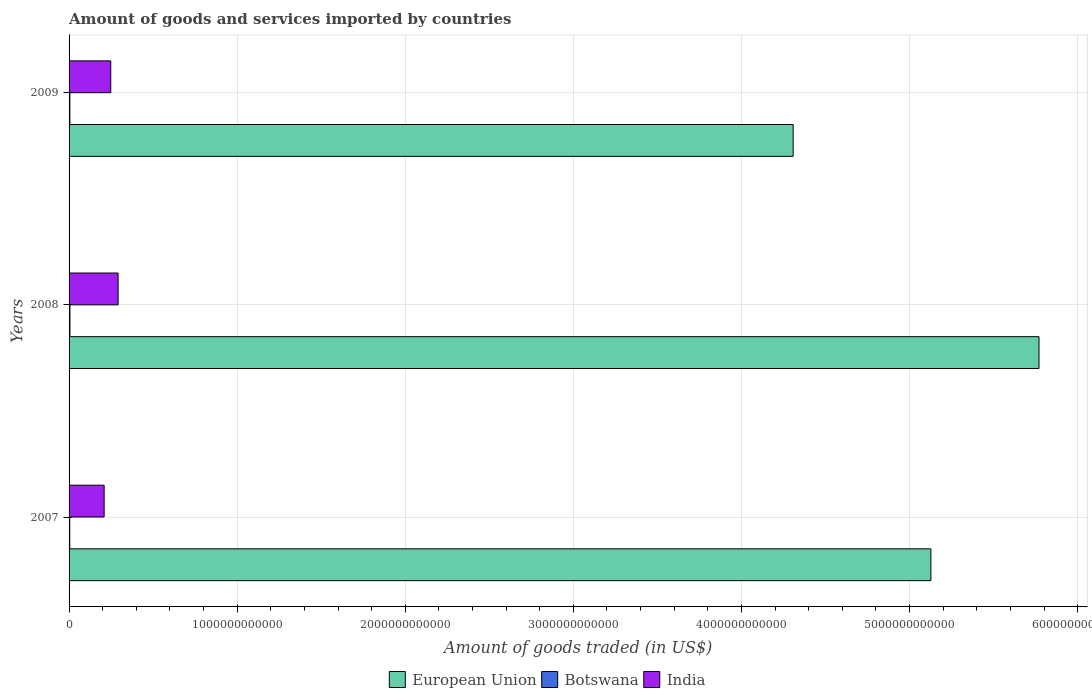How many different coloured bars are there?
Your response must be concise. 3. In how many cases, is the number of bars for a given year not equal to the number of legend labels?
Give a very brief answer. 0. What is the total amount of goods and services imported in Botswana in 2007?
Offer a terse response. 4.01e+09. Across all years, what is the maximum total amount of goods and services imported in European Union?
Make the answer very short. 5.77e+12. Across all years, what is the minimum total amount of goods and services imported in Botswana?
Offer a terse response. 4.01e+09. What is the total total amount of goods and services imported in European Union in the graph?
Give a very brief answer. 1.52e+13. What is the difference between the total amount of goods and services imported in Botswana in 2008 and that in 2009?
Give a very brief answer. 5.15e+08. What is the difference between the total amount of goods and services imported in Botswana in 2008 and the total amount of goods and services imported in European Union in 2007?
Give a very brief answer. -5.12e+12. What is the average total amount of goods and services imported in Botswana per year?
Offer a terse response. 4.61e+09. In the year 2008, what is the difference between the total amount of goods and services imported in Botswana and total amount of goods and services imported in European Union?
Give a very brief answer. -5.77e+12. What is the ratio of the total amount of goods and services imported in European Union in 2007 to that in 2009?
Your answer should be very brief. 1.19. Is the total amount of goods and services imported in Botswana in 2008 less than that in 2009?
Offer a very short reply. No. Is the difference between the total amount of goods and services imported in Botswana in 2008 and 2009 greater than the difference between the total amount of goods and services imported in European Union in 2008 and 2009?
Give a very brief answer. No. What is the difference between the highest and the second highest total amount of goods and services imported in European Union?
Your answer should be compact. 6.43e+11. What is the difference between the highest and the lowest total amount of goods and services imported in Botswana?
Make the answer very short. 1.17e+09. What does the 2nd bar from the top in 2007 represents?
Provide a short and direct response. Botswana. Is it the case that in every year, the sum of the total amount of goods and services imported in India and total amount of goods and services imported in European Union is greater than the total amount of goods and services imported in Botswana?
Your response must be concise. Yes. Are all the bars in the graph horizontal?
Provide a succinct answer. Yes. How many years are there in the graph?
Your answer should be very brief. 3. What is the difference between two consecutive major ticks on the X-axis?
Offer a terse response. 1.00e+12. Are the values on the major ticks of X-axis written in scientific E-notation?
Your answer should be very brief. No. Where does the legend appear in the graph?
Your answer should be compact. Bottom center. How many legend labels are there?
Your response must be concise. 3. How are the legend labels stacked?
Give a very brief answer. Horizontal. What is the title of the graph?
Provide a succinct answer. Amount of goods and services imported by countries. What is the label or title of the X-axis?
Keep it short and to the point. Amount of goods traded (in US$). What is the label or title of the Y-axis?
Provide a succinct answer. Years. What is the Amount of goods traded (in US$) of European Union in 2007?
Give a very brief answer. 5.13e+12. What is the Amount of goods traded (in US$) of Botswana in 2007?
Offer a terse response. 4.01e+09. What is the Amount of goods traded (in US$) of India in 2007?
Keep it short and to the point. 2.09e+11. What is the Amount of goods traded (in US$) in European Union in 2008?
Keep it short and to the point. 5.77e+12. What is the Amount of goods traded (in US$) in Botswana in 2008?
Your answer should be very brief. 5.18e+09. What is the Amount of goods traded (in US$) in India in 2008?
Your answer should be very brief. 2.92e+11. What is the Amount of goods traded (in US$) in European Union in 2009?
Your answer should be very brief. 4.31e+12. What is the Amount of goods traded (in US$) of Botswana in 2009?
Ensure brevity in your answer.  4.66e+09. What is the Amount of goods traded (in US$) in India in 2009?
Your answer should be very brief. 2.48e+11. Across all years, what is the maximum Amount of goods traded (in US$) of European Union?
Ensure brevity in your answer.  5.77e+12. Across all years, what is the maximum Amount of goods traded (in US$) of Botswana?
Ensure brevity in your answer.  5.18e+09. Across all years, what is the maximum Amount of goods traded (in US$) in India?
Your response must be concise. 2.92e+11. Across all years, what is the minimum Amount of goods traded (in US$) of European Union?
Your answer should be very brief. 4.31e+12. Across all years, what is the minimum Amount of goods traded (in US$) of Botswana?
Offer a terse response. 4.01e+09. Across all years, what is the minimum Amount of goods traded (in US$) of India?
Make the answer very short. 2.09e+11. What is the total Amount of goods traded (in US$) in European Union in the graph?
Give a very brief answer. 1.52e+13. What is the total Amount of goods traded (in US$) of Botswana in the graph?
Your answer should be very brief. 1.38e+1. What is the total Amount of goods traded (in US$) in India in the graph?
Keep it short and to the point. 7.48e+11. What is the difference between the Amount of goods traded (in US$) in European Union in 2007 and that in 2008?
Offer a very short reply. -6.43e+11. What is the difference between the Amount of goods traded (in US$) in Botswana in 2007 and that in 2008?
Offer a very short reply. -1.17e+09. What is the difference between the Amount of goods traded (in US$) of India in 2007 and that in 2008?
Your response must be concise. -8.31e+1. What is the difference between the Amount of goods traded (in US$) of European Union in 2007 and that in 2009?
Provide a succinct answer. 8.19e+11. What is the difference between the Amount of goods traded (in US$) in Botswana in 2007 and that in 2009?
Keep it short and to the point. -6.53e+08. What is the difference between the Amount of goods traded (in US$) of India in 2007 and that in 2009?
Provide a succinct answer. -3.93e+1. What is the difference between the Amount of goods traded (in US$) of European Union in 2008 and that in 2009?
Keep it short and to the point. 1.46e+12. What is the difference between the Amount of goods traded (in US$) in Botswana in 2008 and that in 2009?
Provide a short and direct response. 5.15e+08. What is the difference between the Amount of goods traded (in US$) in India in 2008 and that in 2009?
Provide a short and direct response. 4.38e+1. What is the difference between the Amount of goods traded (in US$) of European Union in 2007 and the Amount of goods traded (in US$) of Botswana in 2008?
Your response must be concise. 5.12e+12. What is the difference between the Amount of goods traded (in US$) of European Union in 2007 and the Amount of goods traded (in US$) of India in 2008?
Offer a very short reply. 4.84e+12. What is the difference between the Amount of goods traded (in US$) of Botswana in 2007 and the Amount of goods traded (in US$) of India in 2008?
Offer a very short reply. -2.88e+11. What is the difference between the Amount of goods traded (in US$) of European Union in 2007 and the Amount of goods traded (in US$) of Botswana in 2009?
Make the answer very short. 5.12e+12. What is the difference between the Amount of goods traded (in US$) in European Union in 2007 and the Amount of goods traded (in US$) in India in 2009?
Give a very brief answer. 4.88e+12. What is the difference between the Amount of goods traded (in US$) in Botswana in 2007 and the Amount of goods traded (in US$) in India in 2009?
Your answer should be very brief. -2.44e+11. What is the difference between the Amount of goods traded (in US$) in European Union in 2008 and the Amount of goods traded (in US$) in Botswana in 2009?
Your answer should be very brief. 5.77e+12. What is the difference between the Amount of goods traded (in US$) in European Union in 2008 and the Amount of goods traded (in US$) in India in 2009?
Offer a terse response. 5.52e+12. What is the difference between the Amount of goods traded (in US$) of Botswana in 2008 and the Amount of goods traded (in US$) of India in 2009?
Give a very brief answer. -2.43e+11. What is the average Amount of goods traded (in US$) in European Union per year?
Provide a short and direct response. 5.07e+12. What is the average Amount of goods traded (in US$) of Botswana per year?
Offer a terse response. 4.61e+09. What is the average Amount of goods traded (in US$) of India per year?
Provide a succinct answer. 2.49e+11. In the year 2007, what is the difference between the Amount of goods traded (in US$) in European Union and Amount of goods traded (in US$) in Botswana?
Give a very brief answer. 5.12e+12. In the year 2007, what is the difference between the Amount of goods traded (in US$) in European Union and Amount of goods traded (in US$) in India?
Provide a short and direct response. 4.92e+12. In the year 2007, what is the difference between the Amount of goods traded (in US$) in Botswana and Amount of goods traded (in US$) in India?
Give a very brief answer. -2.05e+11. In the year 2008, what is the difference between the Amount of goods traded (in US$) of European Union and Amount of goods traded (in US$) of Botswana?
Ensure brevity in your answer.  5.77e+12. In the year 2008, what is the difference between the Amount of goods traded (in US$) of European Union and Amount of goods traded (in US$) of India?
Ensure brevity in your answer.  5.48e+12. In the year 2008, what is the difference between the Amount of goods traded (in US$) of Botswana and Amount of goods traded (in US$) of India?
Provide a short and direct response. -2.87e+11. In the year 2009, what is the difference between the Amount of goods traded (in US$) of European Union and Amount of goods traded (in US$) of Botswana?
Provide a succinct answer. 4.30e+12. In the year 2009, what is the difference between the Amount of goods traded (in US$) of European Union and Amount of goods traded (in US$) of India?
Your answer should be very brief. 4.06e+12. In the year 2009, what is the difference between the Amount of goods traded (in US$) in Botswana and Amount of goods traded (in US$) in India?
Make the answer very short. -2.43e+11. What is the ratio of the Amount of goods traded (in US$) of European Union in 2007 to that in 2008?
Your response must be concise. 0.89. What is the ratio of the Amount of goods traded (in US$) of Botswana in 2007 to that in 2008?
Offer a terse response. 0.77. What is the ratio of the Amount of goods traded (in US$) of India in 2007 to that in 2008?
Ensure brevity in your answer.  0.72. What is the ratio of the Amount of goods traded (in US$) in European Union in 2007 to that in 2009?
Your answer should be very brief. 1.19. What is the ratio of the Amount of goods traded (in US$) in Botswana in 2007 to that in 2009?
Keep it short and to the point. 0.86. What is the ratio of the Amount of goods traded (in US$) in India in 2007 to that in 2009?
Give a very brief answer. 0.84. What is the ratio of the Amount of goods traded (in US$) of European Union in 2008 to that in 2009?
Offer a terse response. 1.34. What is the ratio of the Amount of goods traded (in US$) of Botswana in 2008 to that in 2009?
Ensure brevity in your answer.  1.11. What is the ratio of the Amount of goods traded (in US$) of India in 2008 to that in 2009?
Make the answer very short. 1.18. What is the difference between the highest and the second highest Amount of goods traded (in US$) of European Union?
Your answer should be compact. 6.43e+11. What is the difference between the highest and the second highest Amount of goods traded (in US$) in Botswana?
Give a very brief answer. 5.15e+08. What is the difference between the highest and the second highest Amount of goods traded (in US$) of India?
Your response must be concise. 4.38e+1. What is the difference between the highest and the lowest Amount of goods traded (in US$) of European Union?
Keep it short and to the point. 1.46e+12. What is the difference between the highest and the lowest Amount of goods traded (in US$) in Botswana?
Offer a very short reply. 1.17e+09. What is the difference between the highest and the lowest Amount of goods traded (in US$) in India?
Make the answer very short. 8.31e+1. 